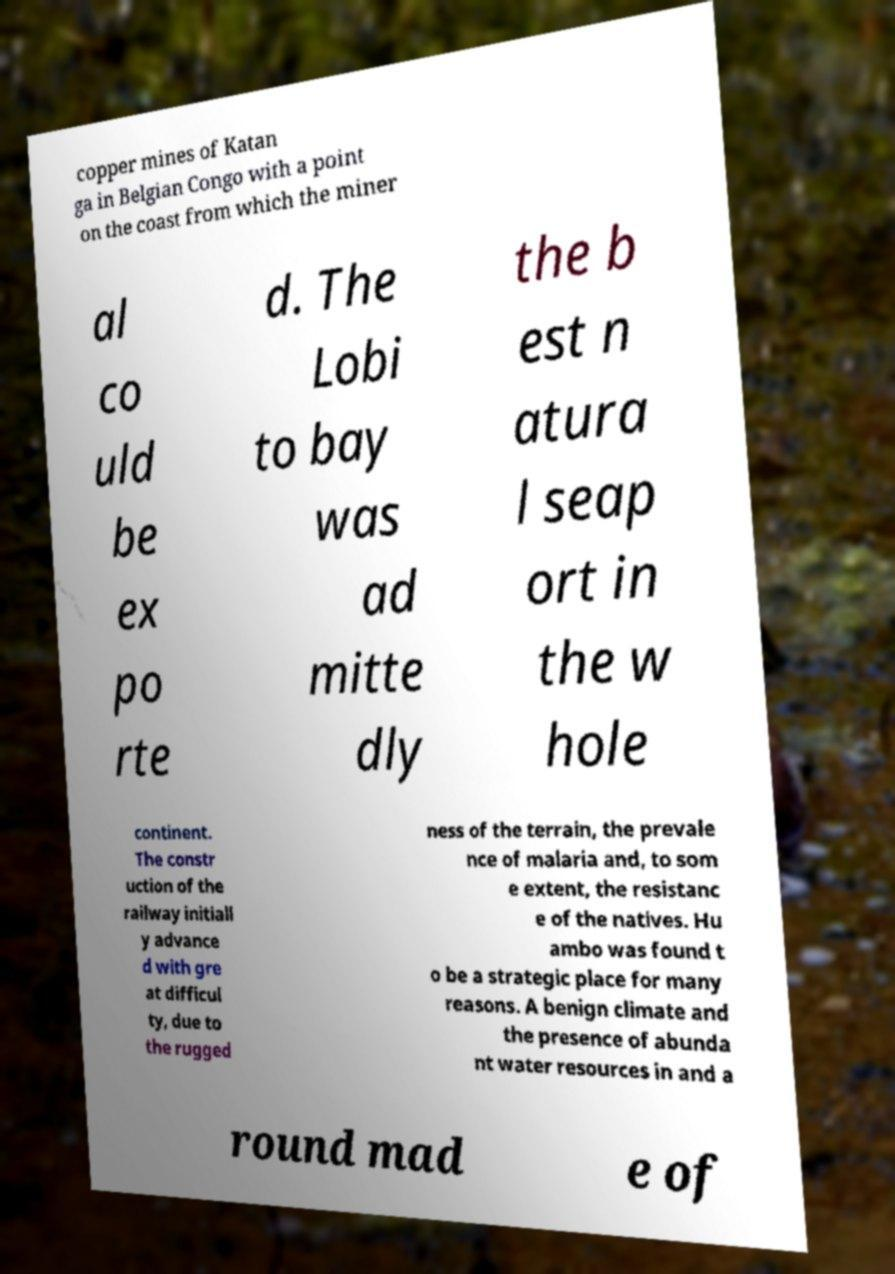For documentation purposes, I need the text within this image transcribed. Could you provide that? copper mines of Katan ga in Belgian Congo with a point on the coast from which the miner al co uld be ex po rte d. The Lobi to bay was ad mitte dly the b est n atura l seap ort in the w hole continent. The constr uction of the railway initiall y advance d with gre at difficul ty, due to the rugged ness of the terrain, the prevale nce of malaria and, to som e extent, the resistanc e of the natives. Hu ambo was found t o be a strategic place for many reasons. A benign climate and the presence of abunda nt water resources in and a round mad e of 